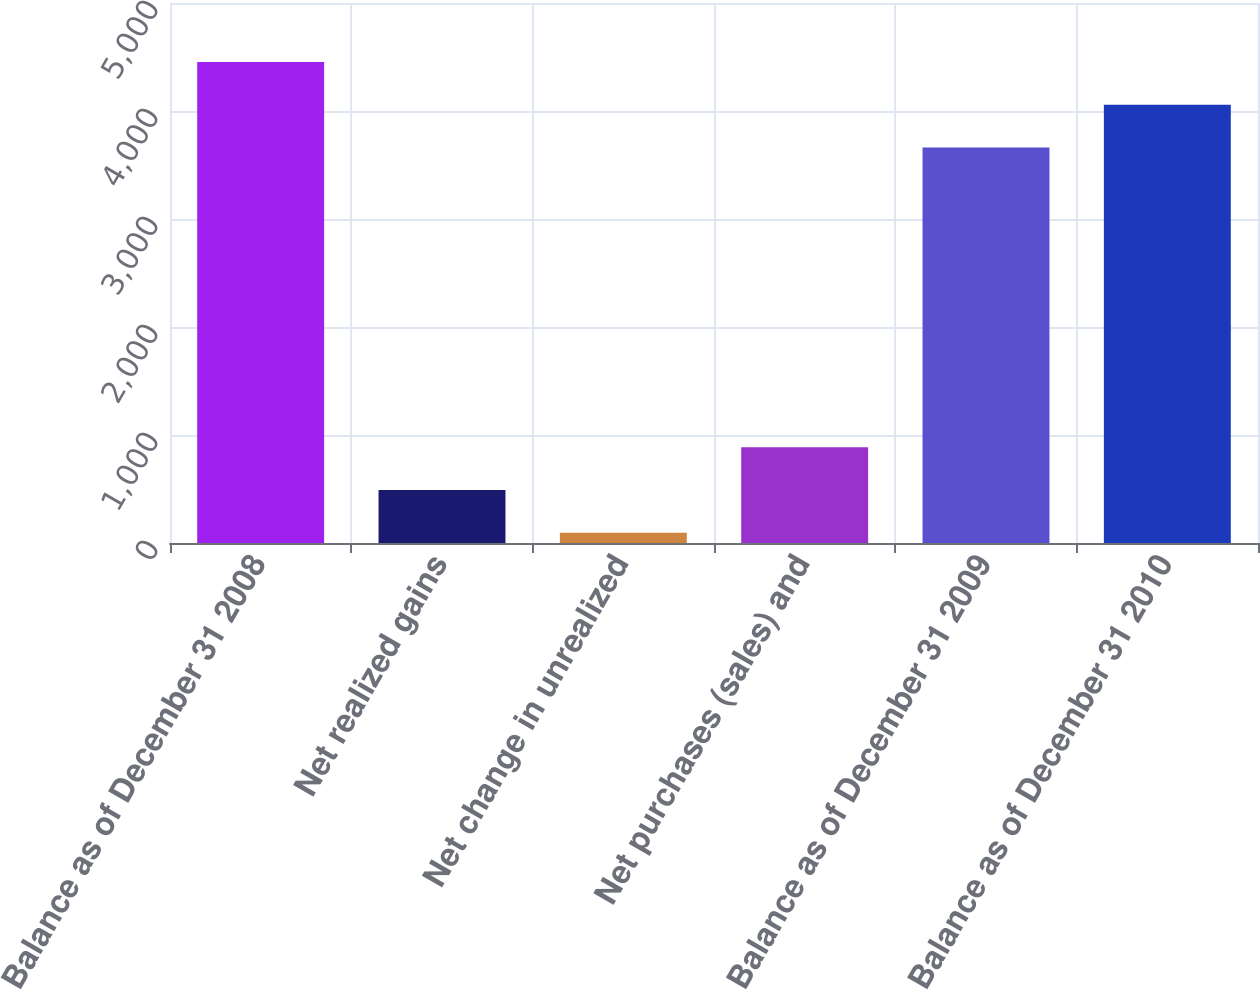Convert chart. <chart><loc_0><loc_0><loc_500><loc_500><bar_chart><fcel>Balance as of December 31 2008<fcel>Net realized gains<fcel>Net change in unrealized<fcel>Net purchases (sales) and<fcel>Balance as of December 31 2009<fcel>Balance as of December 31 2010<nl><fcel>4454.4<fcel>490.2<fcel>94<fcel>886.4<fcel>3662<fcel>4058.2<nl></chart> 